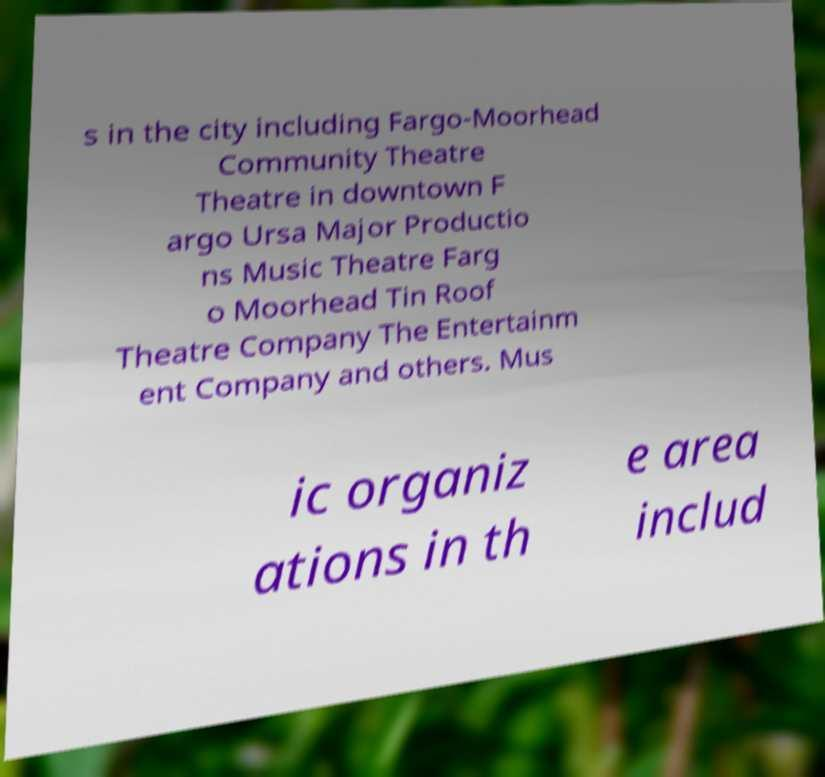Could you assist in decoding the text presented in this image and type it out clearly? s in the city including Fargo-Moorhead Community Theatre Theatre in downtown F argo Ursa Major Productio ns Music Theatre Farg o Moorhead Tin Roof Theatre Company The Entertainm ent Company and others. Mus ic organiz ations in th e area includ 